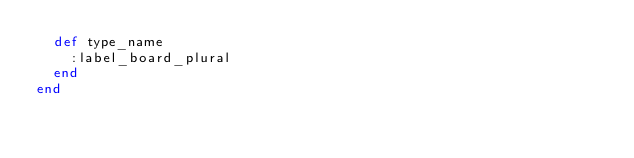Convert code to text. <code><loc_0><loc_0><loc_500><loc_500><_Ruby_>  def type_name
    :label_board_plural
  end
end


</code> 